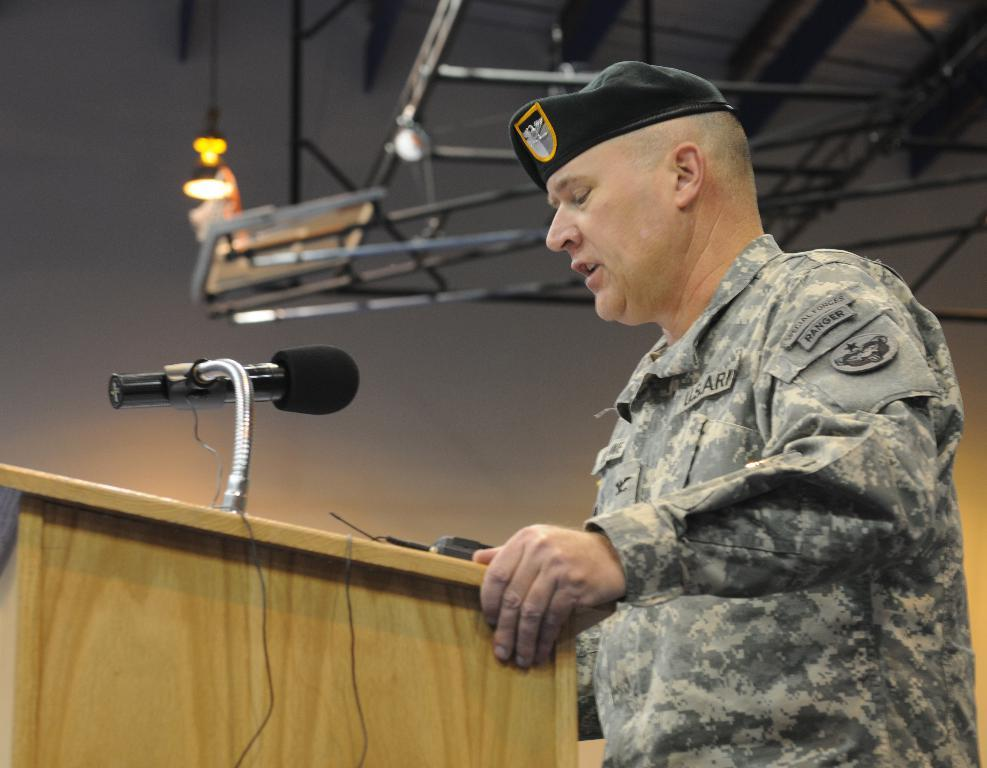What is the person in the image doing? The person is standing at a podium. What is attached to the podium? A microphone is attached to the podium. What can be seen in the background of the image? There are electric lights, grills, and the sky visible in the background. What type of noise is the porter making in the image? There is no porter present in the image, and therefore no noise can be attributed to a porter. 